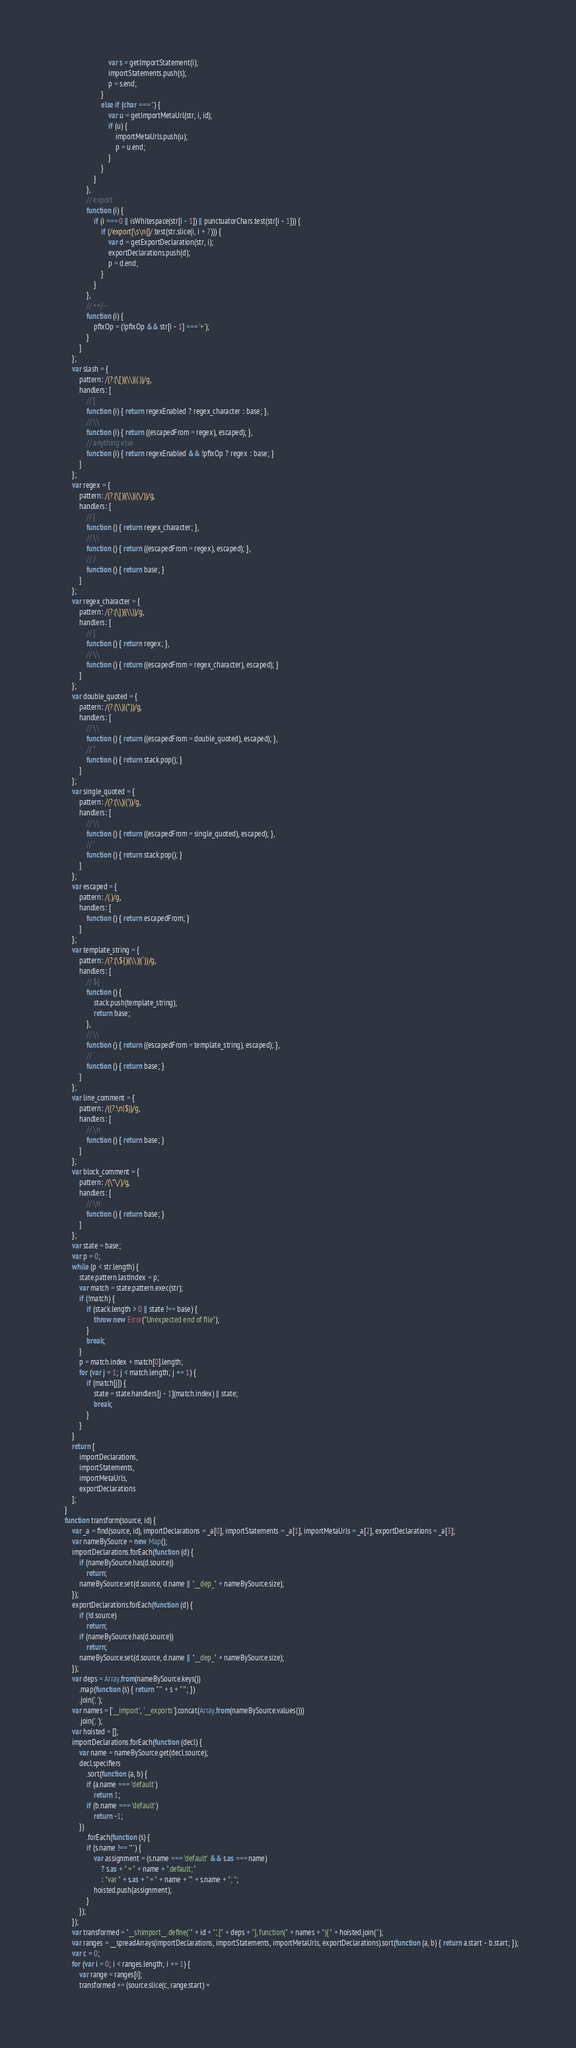<code> <loc_0><loc_0><loc_500><loc_500><_JavaScript_>                            var s = getImportStatement(i);
                            importStatements.push(s);
                            p = s.end;
                        }
                        else if (char === '.') {
                            var u = getImportMetaUrl(str, i, id);
                            if (u) {
                                importMetaUrls.push(u);
                                p = u.end;
                            }
                        }
                    }
                },
                // export
                function (i) {
                    if (i === 0 || isWhitespace(str[i - 1]) || punctuatorChars.test(str[i - 1])) {
                        if (/export[\s\n{]/.test(str.slice(i, i + 7))) {
                            var d = getExportDeclaration(str, i);
                            exportDeclarations.push(d);
                            p = d.end;
                        }
                    }
                },
                // ++/--
                function (i) {
                    pfixOp = (!pfixOp && str[i - 1] === '+');
                }
            ]
        };
        var slash = {
            pattern: /(?:(\[)|(\\)|(.))/g,
            handlers: [
                // [
                function (i) { return regexEnabled ? regex_character : base; },
                // \\
                function (i) { return ((escapedFrom = regex), escaped); },
                // anything else
                function (i) { return regexEnabled && !pfixOp ? regex : base; }
            ]
        };
        var regex = {
            pattern: /(?:(\[)|(\\)|(\/))/g,
            handlers: [
                // [
                function () { return regex_character; },
                // \\
                function () { return ((escapedFrom = regex), escaped); },
                // /
                function () { return base; }
            ]
        };
        var regex_character = {
            pattern: /(?:(\])|(\\))/g,
            handlers: [
                // ]
                function () { return regex; },
                // \\
                function () { return ((escapedFrom = regex_character), escaped); }
            ]
        };
        var double_quoted = {
            pattern: /(?:(\\)|("))/g,
            handlers: [
                // \\
                function () { return ((escapedFrom = double_quoted), escaped); },
                // "
                function () { return stack.pop(); }
            ]
        };
        var single_quoted = {
            pattern: /(?:(\\)|('))/g,
            handlers: [
                // \\
                function () { return ((escapedFrom = single_quoted), escaped); },
                // '
                function () { return stack.pop(); }
            ]
        };
        var escaped = {
            pattern: /(.)/g,
            handlers: [
                function () { return escapedFrom; }
            ]
        };
        var template_string = {
            pattern: /(?:(\${)|(\\)|(`))/g,
            handlers: [
                // ${
                function () {
                    stack.push(template_string);
                    return base;
                },
                // \\
                function () { return ((escapedFrom = template_string), escaped); },
                // `
                function () { return base; }
            ]
        };
        var line_comment = {
            pattern: /((?:\n|$))/g,
            handlers: [
                // \n
                function () { return base; }
            ]
        };
        var block_comment = {
            pattern: /(\*\/)/g,
            handlers: [
                // \n
                function () { return base; }
            ]
        };
        var state = base;
        var p = 0;
        while (p < str.length) {
            state.pattern.lastIndex = p;
            var match = state.pattern.exec(str);
            if (!match) {
                if (stack.length > 0 || state !== base) {
                    throw new Error("Unexpected end of file");
                }
                break;
            }
            p = match.index + match[0].length;
            for (var j = 1; j < match.length; j += 1) {
                if (match[j]) {
                    state = state.handlers[j - 1](match.index) || state;
                    break;
                }
            }
        }
        return [
            importDeclarations,
            importStatements,
            importMetaUrls,
            exportDeclarations
        ];
    }
    function transform(source, id) {
        var _a = find(source, id), importDeclarations = _a[0], importStatements = _a[1], importMetaUrls = _a[2], exportDeclarations = _a[3];
        var nameBySource = new Map();
        importDeclarations.forEach(function (d) {
            if (nameBySource.has(d.source))
                return;
            nameBySource.set(d.source, d.name || "__dep_" + nameBySource.size);
        });
        exportDeclarations.forEach(function (d) {
            if (!d.source)
                return;
            if (nameBySource.has(d.source))
                return;
            nameBySource.set(d.source, d.name || "__dep_" + nameBySource.size);
        });
        var deps = Array.from(nameBySource.keys())
            .map(function (s) { return "'" + s + "'"; })
            .join(', ');
        var names = ['__import', '__exports'].concat(Array.from(nameBySource.values()))
            .join(', ');
        var hoisted = [];
        importDeclarations.forEach(function (decl) {
            var name = nameBySource.get(decl.source);
            decl.specifiers
                .sort(function (a, b) {
                if (a.name === 'default')
                    return 1;
                if (b.name === 'default')
                    return -1;
            })
                .forEach(function (s) {
                if (s.name !== '*') {
                    var assignment = (s.name === 'default' && s.as === name)
                        ? s.as + " = " + name + ".default; "
                        : "var " + s.as + " = " + name + "." + s.name + "; ";
                    hoisted.push(assignment);
                }
            });
        });
        var transformed = "__shimport__.define('" + id + "', [" + deps + "], function(" + names + "){ " + hoisted.join('');
        var ranges = __spreadArrays(importDeclarations, importStatements, importMetaUrls, exportDeclarations).sort(function (a, b) { return a.start - b.start; });
        var c = 0;
        for (var i = 0; i < ranges.length; i += 1) {
            var range = ranges[i];
            transformed += (source.slice(c, range.start) +</code> 